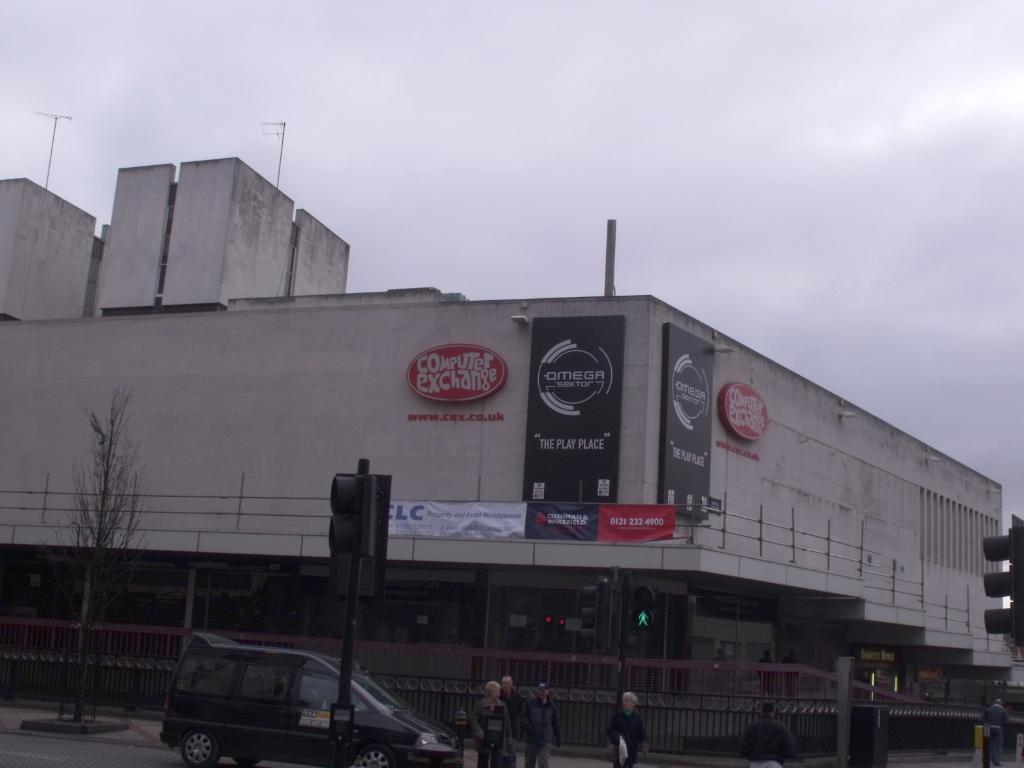Could you give a brief overview of what you see in this image? In this image there is a building, railings, banners, boards, poles, signal lights, vehicle, people, plant, cloudy sky and objects. 